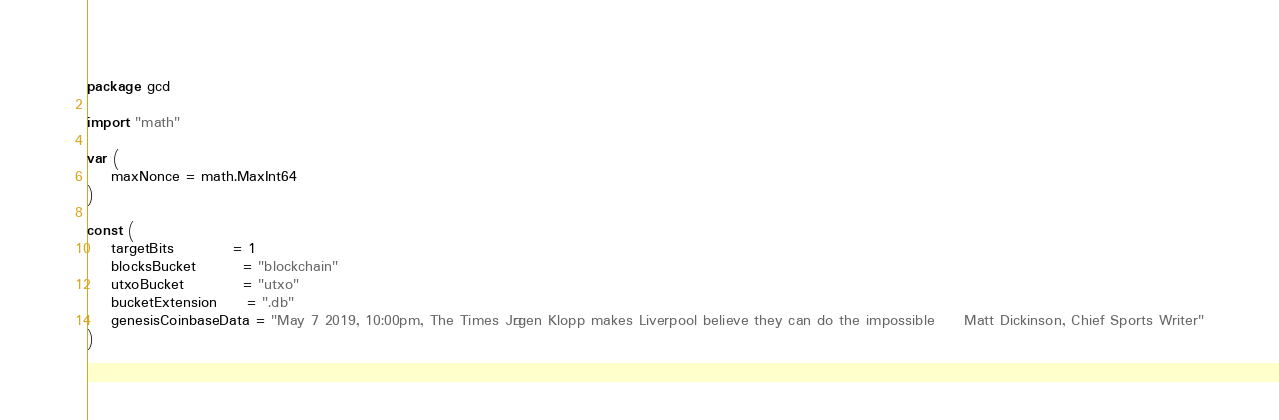Convert code to text. <code><loc_0><loc_0><loc_500><loc_500><_Go_>package gcd

import "math"

var (
	maxNonce = math.MaxInt64
)

const (
	targetBits          = 1
	blocksBucket        = "blockchain"
	utxoBucket          = "utxo"
	bucketExtension     = ".db"
	genesisCoinbaseData = "May 7 2019, 10:00pm, The Times	Jürgen Klopp makes Liverpool believe they can do the impossible		Matt Dickinson, Chief Sports Writer"
)
</code> 